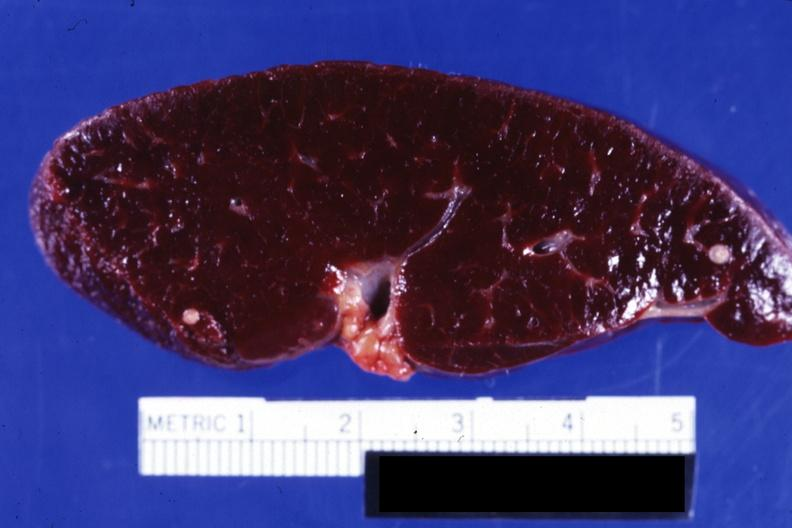what is present?
Answer the question using a single word or phrase. Spleen 